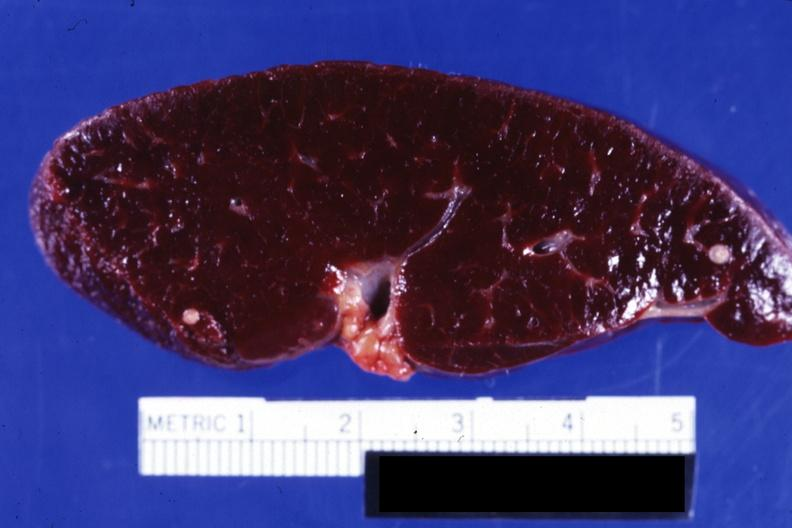what is present?
Answer the question using a single word or phrase. Spleen 